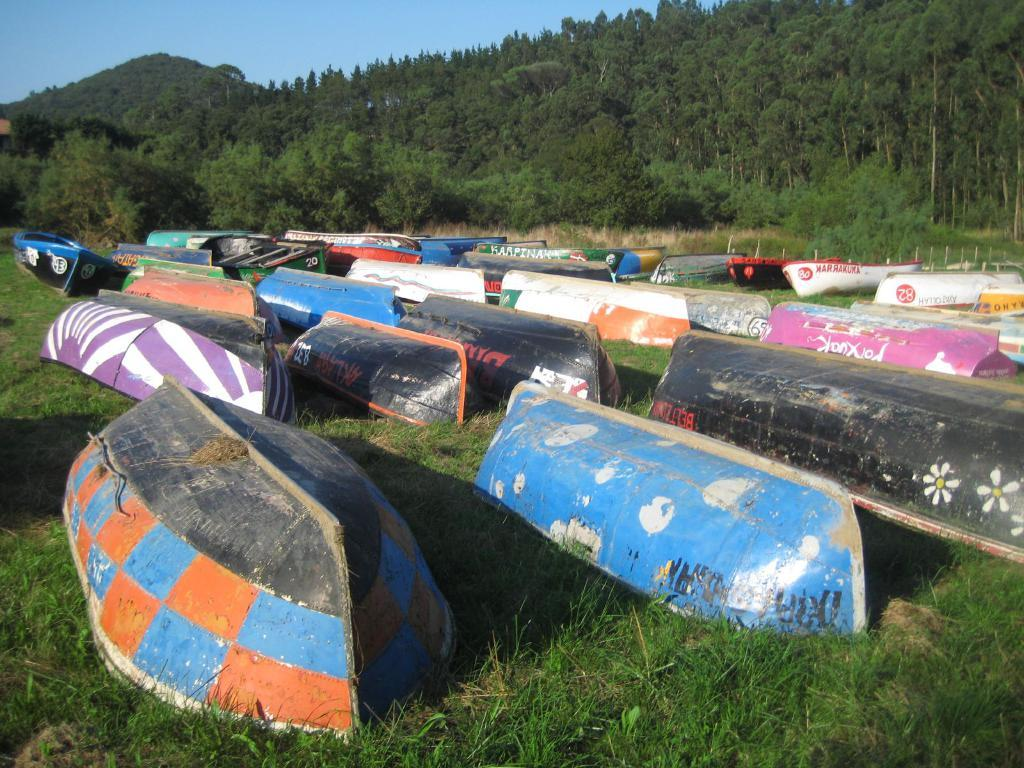What is the main subject of the image? The main subject of the image is boats. How are the boats arranged in the image? The boats are placed on the ground in rows. What type of natural environment is visible in the image? There are trees visible in the image. What is visible in the background of the image? The sky is visible in the image. What type of mine can be seen in the image? There is no mine present in the image; it features boats placed on the ground in rows. What type of shoes are the boats wearing in the image? Boats do not wear shoes, as they are inanimate objects. --- 